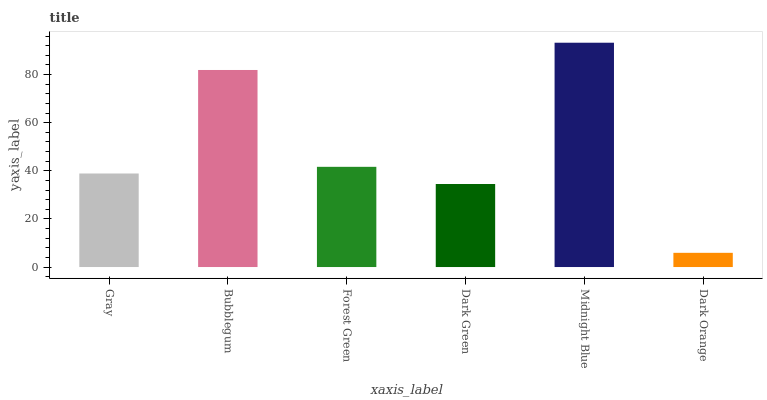Is Dark Orange the minimum?
Answer yes or no. Yes. Is Midnight Blue the maximum?
Answer yes or no. Yes. Is Bubblegum the minimum?
Answer yes or no. No. Is Bubblegum the maximum?
Answer yes or no. No. Is Bubblegum greater than Gray?
Answer yes or no. Yes. Is Gray less than Bubblegum?
Answer yes or no. Yes. Is Gray greater than Bubblegum?
Answer yes or no. No. Is Bubblegum less than Gray?
Answer yes or no. No. Is Forest Green the high median?
Answer yes or no. Yes. Is Gray the low median?
Answer yes or no. Yes. Is Dark Orange the high median?
Answer yes or no. No. Is Forest Green the low median?
Answer yes or no. No. 